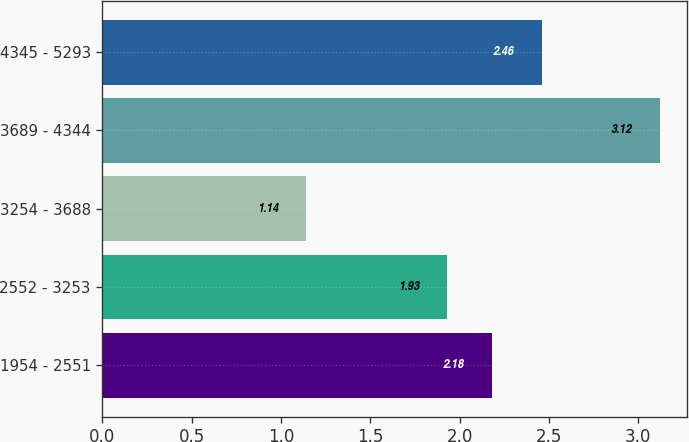Convert chart. <chart><loc_0><loc_0><loc_500><loc_500><bar_chart><fcel>1954 - 2551<fcel>2552 - 3253<fcel>3254 - 3688<fcel>3689 - 4344<fcel>4345 - 5293<nl><fcel>2.18<fcel>1.93<fcel>1.14<fcel>3.12<fcel>2.46<nl></chart> 